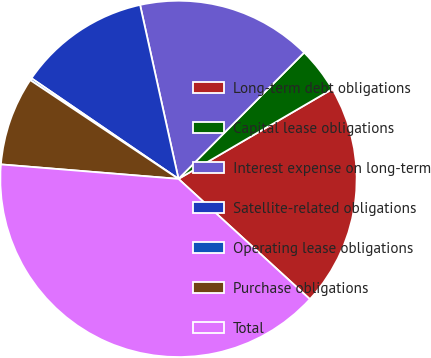Convert chart to OTSL. <chart><loc_0><loc_0><loc_500><loc_500><pie_chart><fcel>Long-term debt obligations<fcel>Capital lease obligations<fcel>Interest expense on long-term<fcel>Satellite-related obligations<fcel>Operating lease obligations<fcel>Purchase obligations<fcel>Total<nl><fcel>20.21%<fcel>4.13%<fcel>15.92%<fcel>11.99%<fcel>0.2%<fcel>8.06%<fcel>39.5%<nl></chart> 